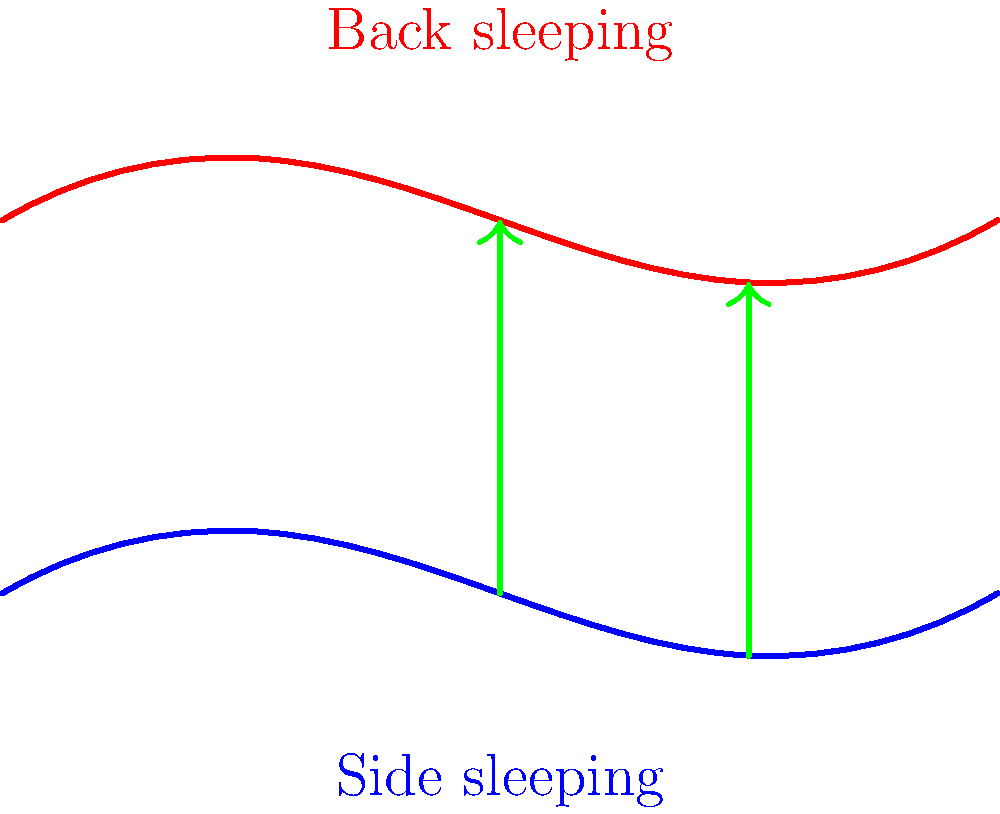Based on the diagram showing spinal alignment in different sleeping positions, which position appears to provide better overall spinal alignment, and why might this be beneficial for a single parent with a demanding job? 1. Analyze the diagram:
   - The blue curve represents side sleeping position
   - The red curve represents back sleeping position
   - Green arrows indicate the alignment between the two positions

2. Compare spinal curvatures:
   - Side sleeping (blue) shows more pronounced curves
   - Back sleeping (red) displays a more neutral, aligned position

3. Evaluate spinal alignment:
   - Back sleeping position demonstrates better overall alignment
   - The spine in back sleeping position has less extreme curves

4. Consider the benefits for a single parent with a demanding job:
   - Better spinal alignment can lead to improved sleep quality
   - Reduced risk of waking up with back pain or discomfort
   - Potentially better rest, leading to increased energy for daily tasks
   - May help in managing stress from work and parenting responsibilities

5. Long-term implications:
   - Consistent better alignment may reduce the risk of chronic back issues
   - Could contribute to overall better health and well-being

6. Practical considerations:
   - Back sleeping might be easier to maintain throughout the night
   - Could lead to more consistent, uninterrupted sleep
Answer: Back sleeping; better spinal alignment improves sleep quality and reduces pain, benefiting a busy single parent. 